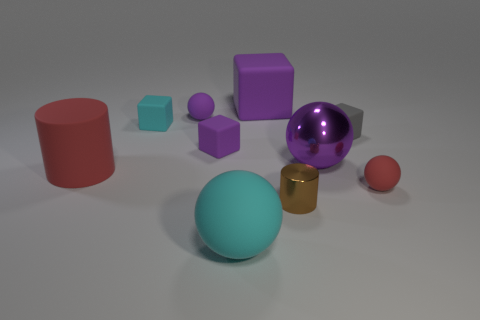What shape is the small matte thing that is the same color as the large matte sphere?
Keep it short and to the point. Cube. Do the gray matte block and the matte ball left of the small purple matte block have the same size?
Make the answer very short. Yes. What size is the purple matte thing in front of the cyan thing that is behind the small sphere to the right of the gray matte object?
Offer a very short reply. Small. There is a cyan matte thing that is right of the cyan block; what size is it?
Offer a terse response. Large. There is a small cyan object that is made of the same material as the big purple cube; what is its shape?
Offer a terse response. Cube. Does the purple sphere that is left of the large purple matte thing have the same material as the tiny red object?
Your answer should be compact. Yes. What number of other things are there of the same material as the cyan cube
Provide a short and direct response. 7. What number of things are purple cubes behind the tiny cyan rubber thing or small blocks that are behind the gray block?
Offer a very short reply. 2. There is a purple matte object on the left side of the tiny purple cube; does it have the same shape as the small rubber object on the left side of the tiny purple matte sphere?
Keep it short and to the point. No. There is a metal thing that is the same size as the red rubber cylinder; what shape is it?
Offer a terse response. Sphere. 